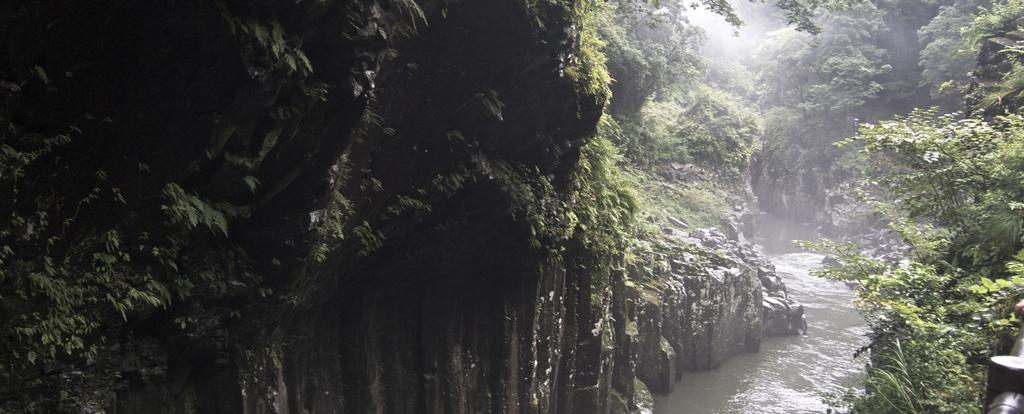What type of vegetation can be seen in the image? There are trees and creeper plants in the image. What other natural elements are present in the image? There are rocks in the image. What body of water is visible in the image? There is a lake in the image. What type of writing can be seen on the rocks in the image? There is no writing present on the rocks in the image. What type of plants are growing on the leg of the person in the image? There is no person or leg present in the image. 